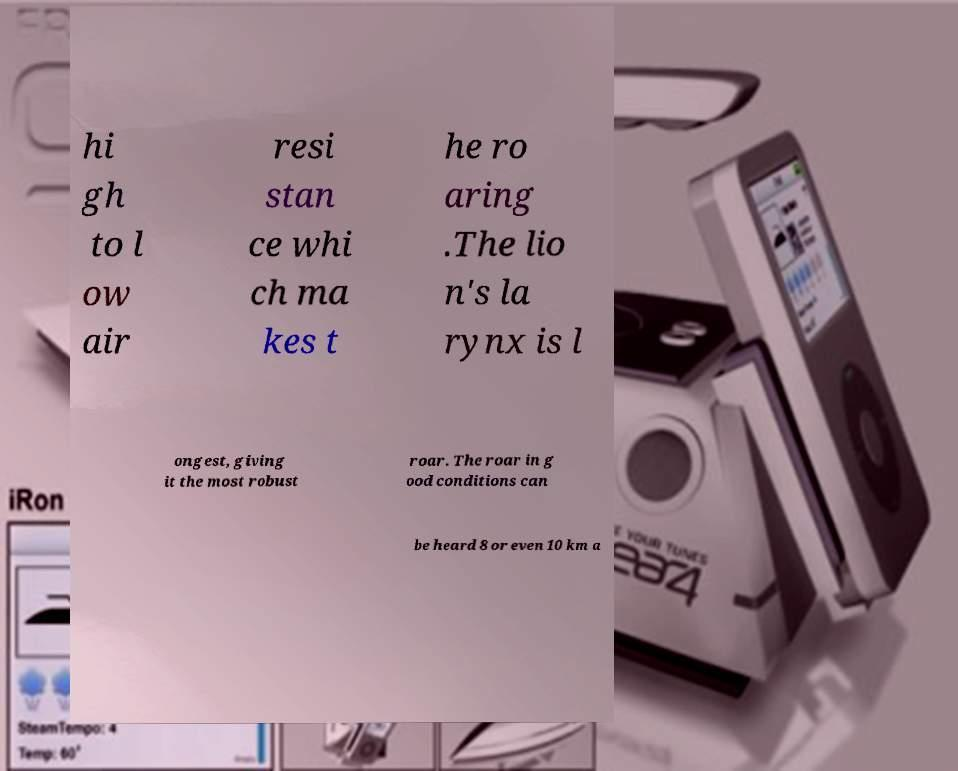Please read and relay the text visible in this image. What does it say? hi gh to l ow air resi stan ce whi ch ma kes t he ro aring .The lio n's la rynx is l ongest, giving it the most robust roar. The roar in g ood conditions can be heard 8 or even 10 km a 